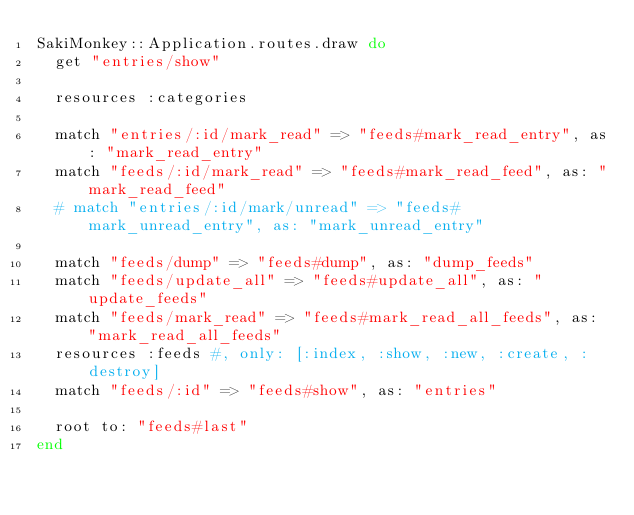<code> <loc_0><loc_0><loc_500><loc_500><_Ruby_>SakiMonkey::Application.routes.draw do
  get "entries/show"

  resources :categories

  match "entries/:id/mark_read" => "feeds#mark_read_entry", as: "mark_read_entry"
  match "feeds/:id/mark_read" => "feeds#mark_read_feed", as: "mark_read_feed"
  # match "entries/:id/mark/unread" => "feeds#mark_unread_entry", as: "mark_unread_entry"

  match "feeds/dump" => "feeds#dump", as: "dump_feeds"
  match "feeds/update_all" => "feeds#update_all", as: "update_feeds"
  match "feeds/mark_read" => "feeds#mark_read_all_feeds", as: "mark_read_all_feeds"
  resources :feeds #, only: [:index, :show, :new, :create, :destroy]
  match "feeds/:id" => "feeds#show", as: "entries"

  root to: "feeds#last"
end
</code> 